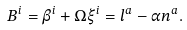Convert formula to latex. <formula><loc_0><loc_0><loc_500><loc_500>B ^ { i } = \beta ^ { i } + \Omega \xi ^ { i } = l ^ { a } - \alpha n ^ { a } .</formula> 